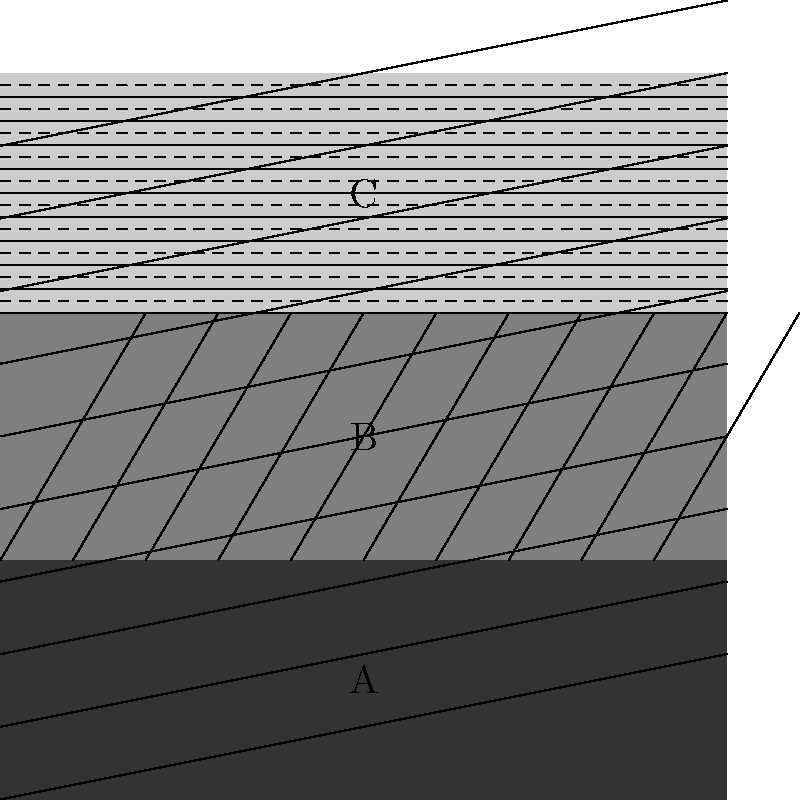In the close-up fabric image above, three distinct texture regions (A, B, and C) are visible. Which machine learning technique would be most appropriate for segmenting these textures, and what feature extraction method would you use to capture the unique characteristics of each texture? To segment the different textures in the close-up fabric image, we need to consider both the machine learning technique and the feature extraction method. Let's break this down step-by-step:

1. Machine Learning Technique:
   The most appropriate technique for this task would be a Convolutional Neural Network (CNN). CNNs are particularly well-suited for image analysis tasks, including texture segmentation, because:
   a) They can automatically learn hierarchical features from the image.
   b) They maintain spatial relationships between pixels.
   c) They are translation-invariant, which is important for texture analysis.

2. Feature Extraction Method:
   While CNNs can learn features automatically, we can enhance their performance by using appropriate feature extraction methods. For texture analysis, we would use:
   a) Gray Level Co-occurrence Matrix (GLCM): This method captures spatial relationships between pixels and can extract features like contrast, correlation, and homogeneity.
   b) Local Binary Patterns (LBP): LBP is effective in capturing local texture patterns and is invariant to monotonic gray-scale transformations.
   c) Gabor filters: These can capture frequency and orientation information, which is crucial for distinguishing between different textures.

3. Implementation:
   a) Preprocess the image by applying the feature extraction methods (GLCM, LBP, and Gabor filters) to create a multi-channel input.
   b) Design a CNN architecture with multiple convolutional layers, followed by pooling layers and fully connected layers.
   c) Use a pixel-wise classification approach, where each pixel is classified into one of the three texture classes (A, B, or C).
   d) Train the network using labeled data, where each pixel is associated with its correct texture class.
   e) Use techniques like data augmentation to improve the model's generalization ability.

4. Post-processing:
   Apply morphological operations or conditional random fields (CRFs) to refine the segmentation results and ensure spatial consistency.

By combining a CNN with these texture-specific feature extraction methods, we can effectively segment the different textures in the close-up fabric image.
Answer: CNN with GLCM, LBP, and Gabor filter features 